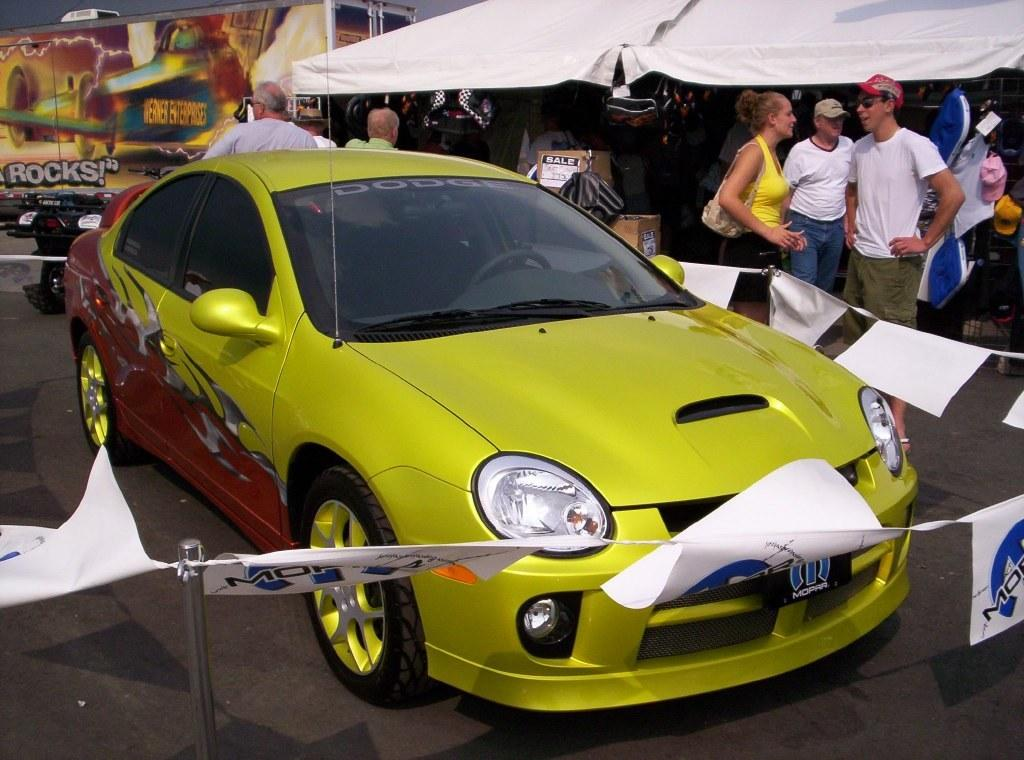What is the main subject of the image? There is a car in the image. What is located around the car? There are papers around the car. What can be seen in the background of the image? There are people, boxes, and a tent in the background of the image. What type of plough is being used by the spy in the image? There is no plough or spy present in the image. What is the spy doing with the quilt in the image? There is no spy or quilt present in the image. 